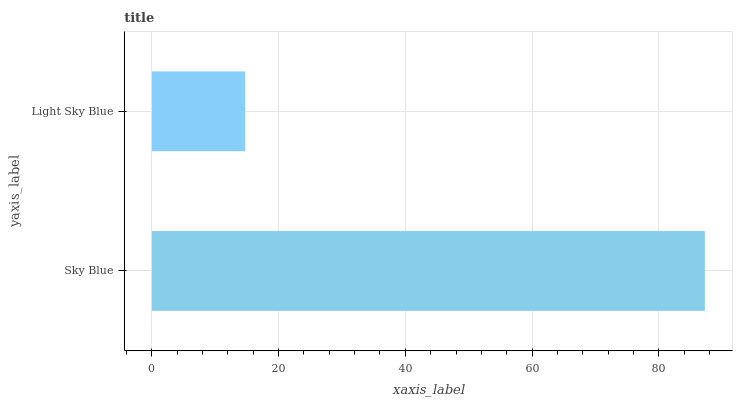Is Light Sky Blue the minimum?
Answer yes or no. Yes. Is Sky Blue the maximum?
Answer yes or no. Yes. Is Light Sky Blue the maximum?
Answer yes or no. No. Is Sky Blue greater than Light Sky Blue?
Answer yes or no. Yes. Is Light Sky Blue less than Sky Blue?
Answer yes or no. Yes. Is Light Sky Blue greater than Sky Blue?
Answer yes or no. No. Is Sky Blue less than Light Sky Blue?
Answer yes or no. No. Is Sky Blue the high median?
Answer yes or no. Yes. Is Light Sky Blue the low median?
Answer yes or no. Yes. Is Light Sky Blue the high median?
Answer yes or no. No. Is Sky Blue the low median?
Answer yes or no. No. 